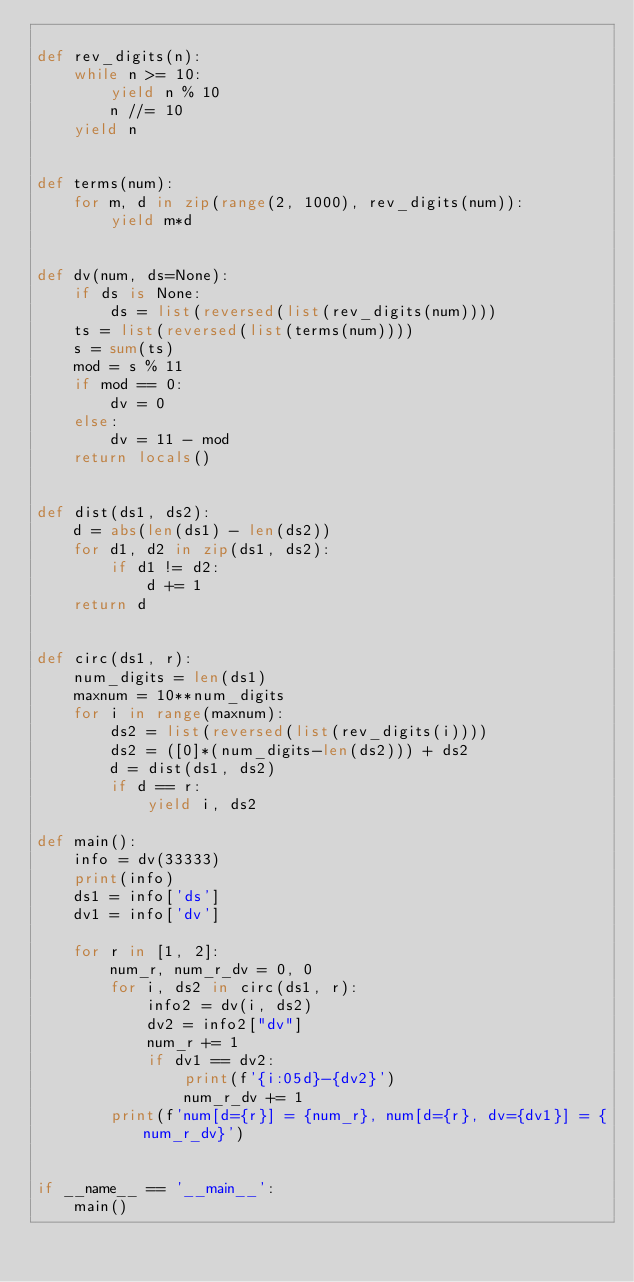Convert code to text. <code><loc_0><loc_0><loc_500><loc_500><_Python_>
def rev_digits(n):
    while n >= 10:
        yield n % 10
        n //= 10
    yield n


def terms(num):
    for m, d in zip(range(2, 1000), rev_digits(num)):
        yield m*d


def dv(num, ds=None):
    if ds is None:
        ds = list(reversed(list(rev_digits(num))))
    ts = list(reversed(list(terms(num))))
    s = sum(ts)
    mod = s % 11
    if mod == 0:
        dv = 0
    else:
        dv = 11 - mod
    return locals()


def dist(ds1, ds2):
    d = abs(len(ds1) - len(ds2))
    for d1, d2 in zip(ds1, ds2):
        if d1 != d2:
            d += 1
    return d


def circ(ds1, r):
    num_digits = len(ds1)
    maxnum = 10**num_digits
    for i in range(maxnum):
        ds2 = list(reversed(list(rev_digits(i))))
        ds2 = ([0]*(num_digits-len(ds2))) + ds2
        d = dist(ds1, ds2)
        if d == r:
            yield i, ds2

def main():
    info = dv(33333)
    print(info)
    ds1 = info['ds']
    dv1 = info['dv']

    for r in [1, 2]:
        num_r, num_r_dv = 0, 0
        for i, ds2 in circ(ds1, r):
            info2 = dv(i, ds2)
            dv2 = info2["dv"]
            num_r += 1
            if dv1 == dv2:
                print(f'{i:05d}-{dv2}')
                num_r_dv += 1
        print(f'num[d={r}] = {num_r}, num[d={r}, dv={dv1}] = {num_r_dv}')


if __name__ == '__main__':
    main()
</code> 